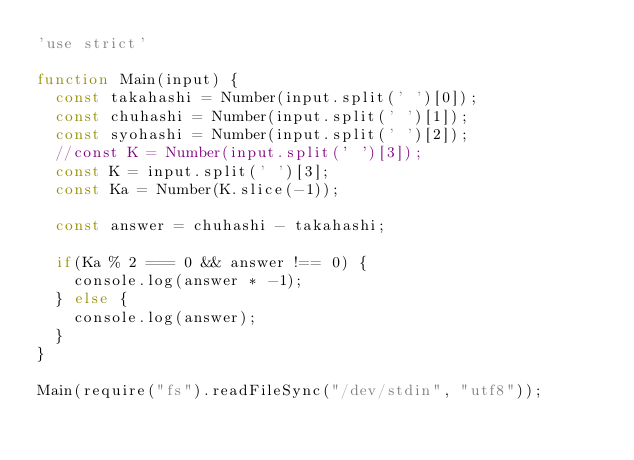<code> <loc_0><loc_0><loc_500><loc_500><_JavaScript_>'use strict'

function Main(input) {
  const takahashi = Number(input.split(' ')[0]);
  const chuhashi = Number(input.split(' ')[1]);
  const syohashi = Number(input.split(' ')[2]);
  //const K = Number(input.split(' ')[3]);
  const K = input.split(' ')[3];
  const Ka = Number(K.slice(-1));

  const answer = chuhashi - takahashi;
  
  if(Ka % 2 === 0 && answer !== 0) {
    console.log(answer * -1);
  } else {
    console.log(answer);
  }
}

Main(require("fs").readFileSync("/dev/stdin", "utf8"));</code> 